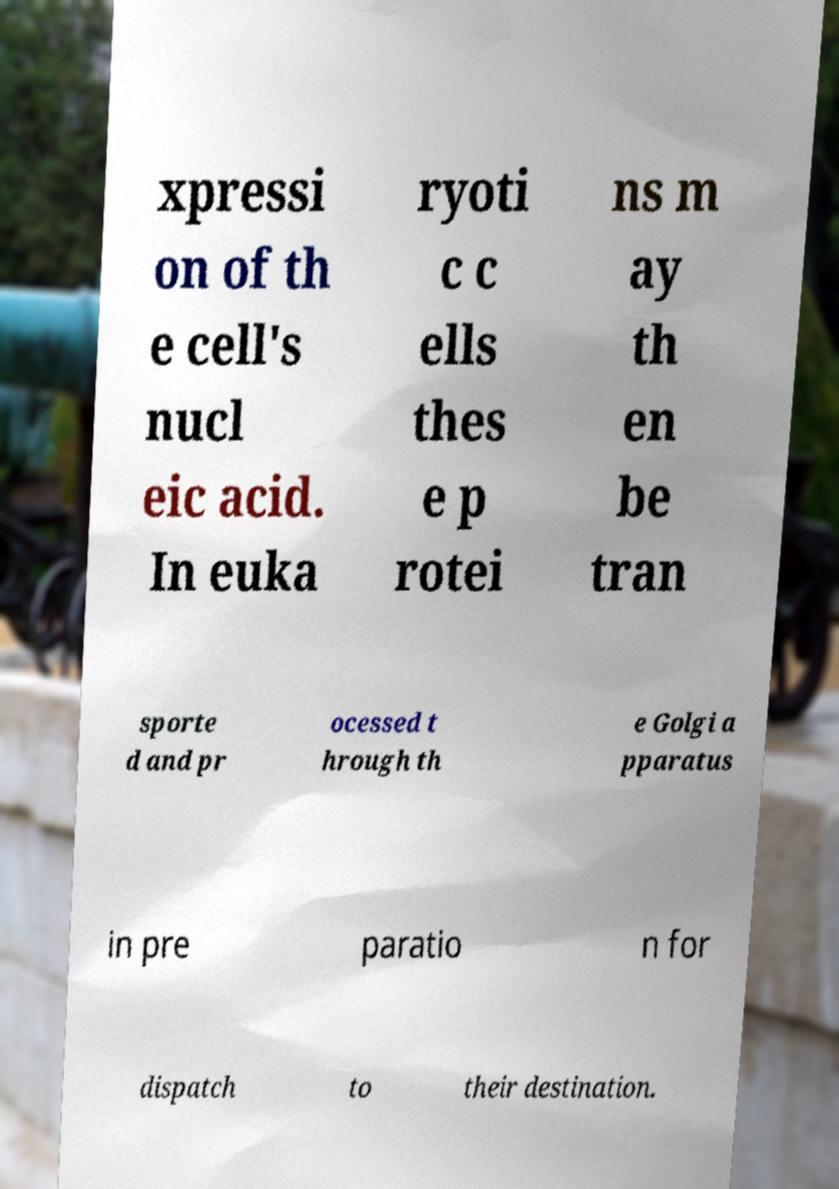For documentation purposes, I need the text within this image transcribed. Could you provide that? xpressi on of th e cell's nucl eic acid. In euka ryoti c c ells thes e p rotei ns m ay th en be tran sporte d and pr ocessed t hrough th e Golgi a pparatus in pre paratio n for dispatch to their destination. 